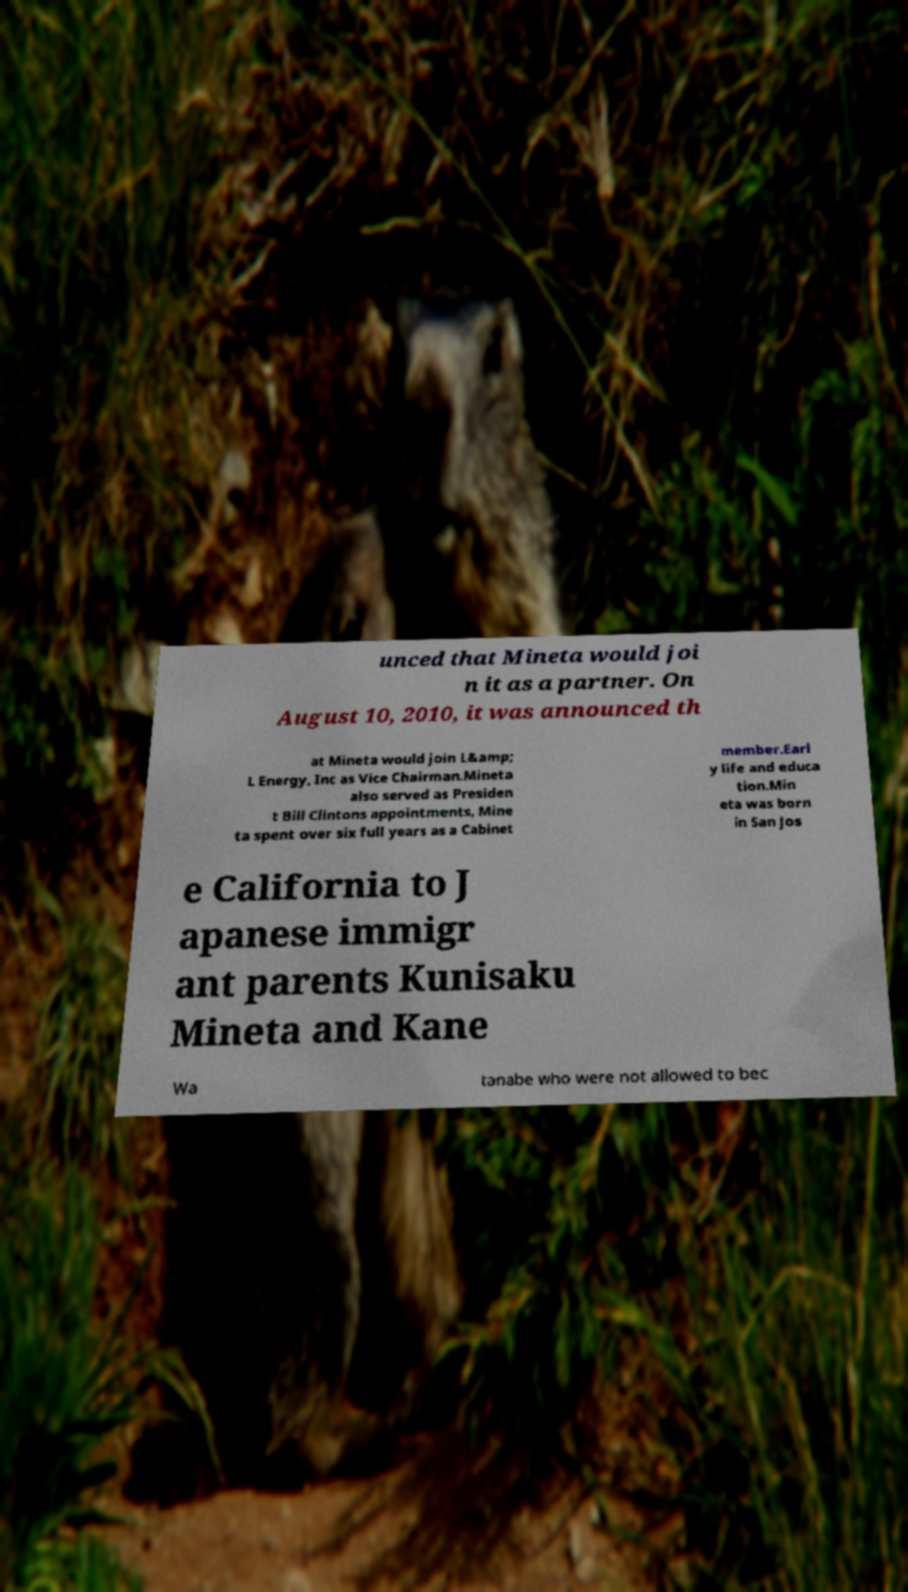What messages or text are displayed in this image? I need them in a readable, typed format. unced that Mineta would joi n it as a partner. On August 10, 2010, it was announced th at Mineta would join L&amp; L Energy, Inc as Vice Chairman.Mineta also served as Presiden t Bill Clintons appointments, Mine ta spent over six full years as a Cabinet member.Earl y life and educa tion.Min eta was born in San Jos e California to J apanese immigr ant parents Kunisaku Mineta and Kane Wa tanabe who were not allowed to bec 